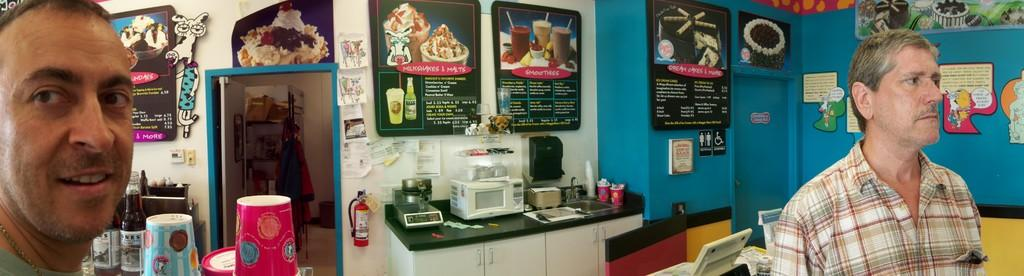How many people are in the image? There are two people in the image. What can be seen in the background of the image? There is a wall in the image, and there are banners visible as well. What objects are present in the image that might be used for serving or drinking? There are glasses and bottles in the image. What type of appliance can be seen in the image? There is an oven in the image. What is used for washing hands or dishes in the image? There is a sink in the image. What safety device is present in the image? There is a fire extinguisher in the image. What electronic devices are visible in the image? There are laptops in the image. What type of animal is the farmer holding in the image? There is no farmer or animal present in the image. What statement is being made by the people in the image? The image does not show any statements being made by the people; it only shows their presence and the objects around them. 